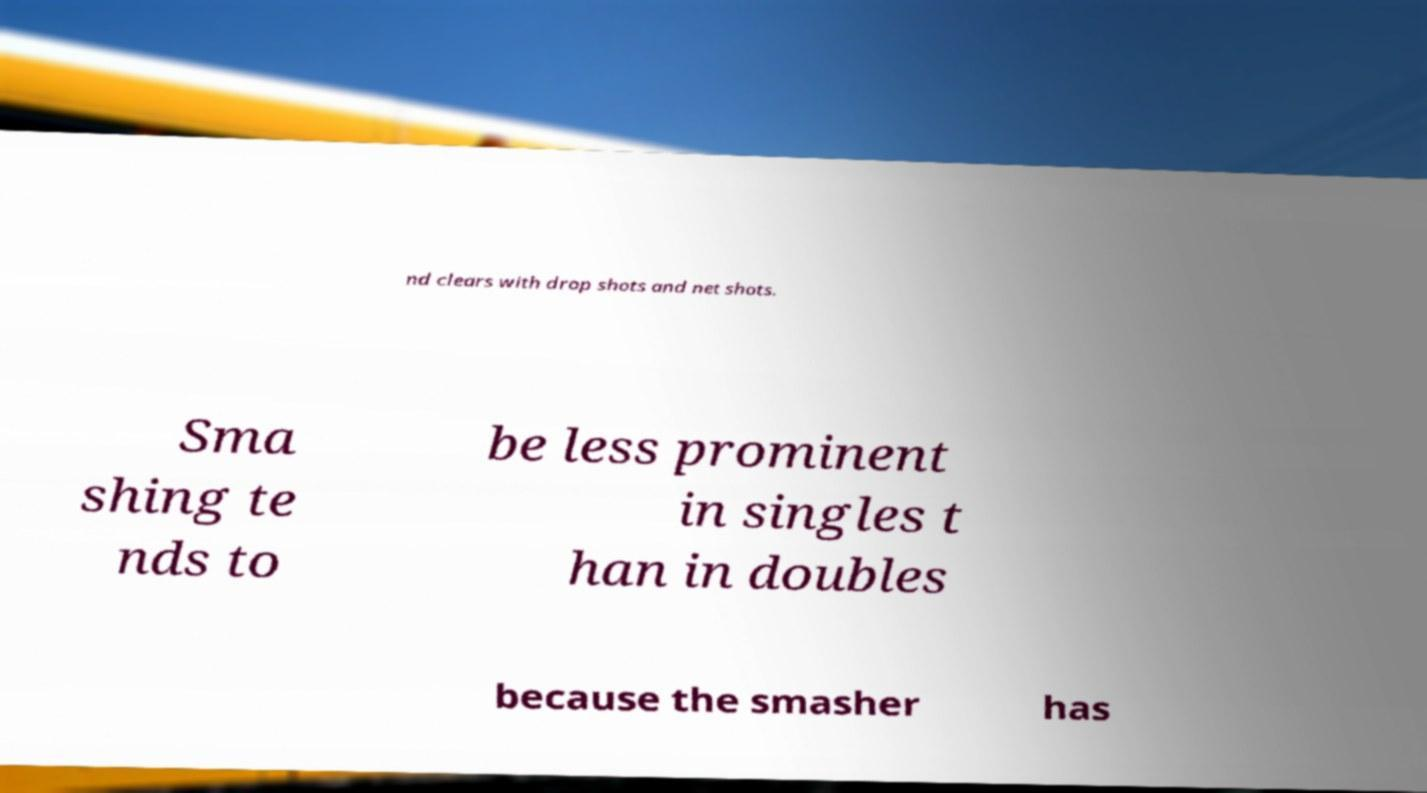Can you accurately transcribe the text from the provided image for me? nd clears with drop shots and net shots. Sma shing te nds to be less prominent in singles t han in doubles because the smasher has 